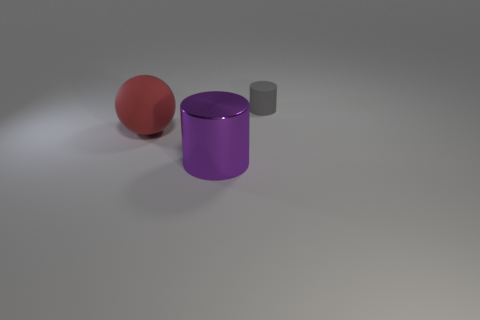Add 1 big matte things. How many objects exist? 4 Subtract all purple cylinders. How many cylinders are left? 1 Subtract 1 cylinders. How many cylinders are left? 1 Subtract all blue balls. Subtract all brown cubes. How many balls are left? 1 Subtract all brown cubes. How many purple spheres are left? 0 Subtract all small things. Subtract all big things. How many objects are left? 0 Add 1 rubber objects. How many rubber objects are left? 3 Add 1 tiny red rubber blocks. How many tiny red rubber blocks exist? 1 Subtract 0 yellow cylinders. How many objects are left? 3 Subtract all spheres. How many objects are left? 2 